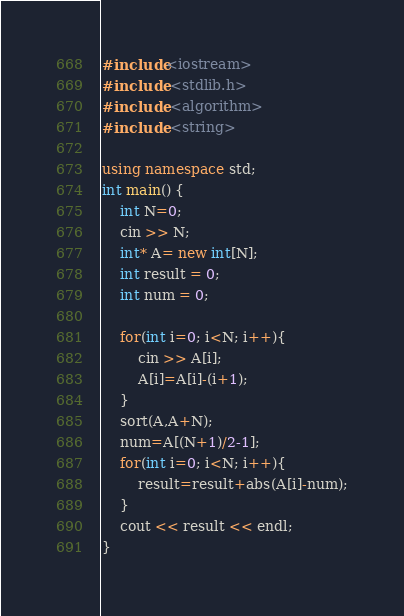Convert code to text. <code><loc_0><loc_0><loc_500><loc_500><_C++_>#include<iostream>
#include <stdlib.h>
#include <algorithm>
#include <string>

using namespace std;
int main() {
    int N=0;
	cin >> N;
	int* A= new int[N];
	int result = 0;
	int num = 0;
	
	for(int i=0; i<N; i++){
		cin >> A[i];
		A[i]=A[i]-(i+1);
	}
	sort(A,A+N);
	num=A[(N+1)/2-1];
	for(int i=0; i<N; i++){
		result=result+abs(A[i]-num);
	}
	cout << result << endl;
}</code> 